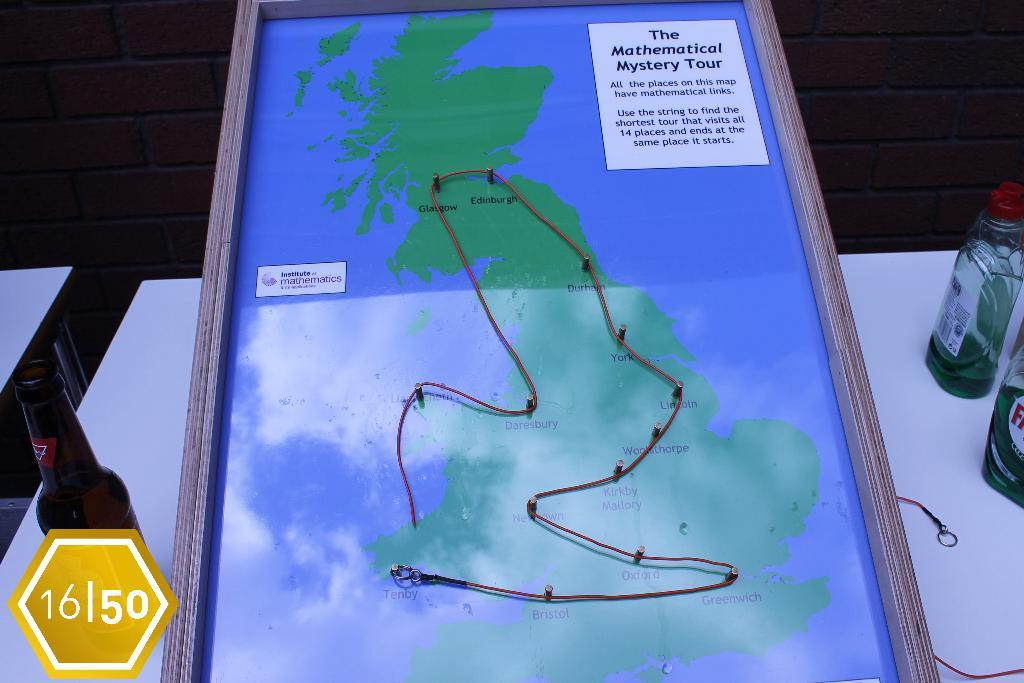<image>
Render a clear and concise summary of the photo. Map with drawing on it with The Mathematical Mystery Tour in black lettering in the upper right hand corner. 